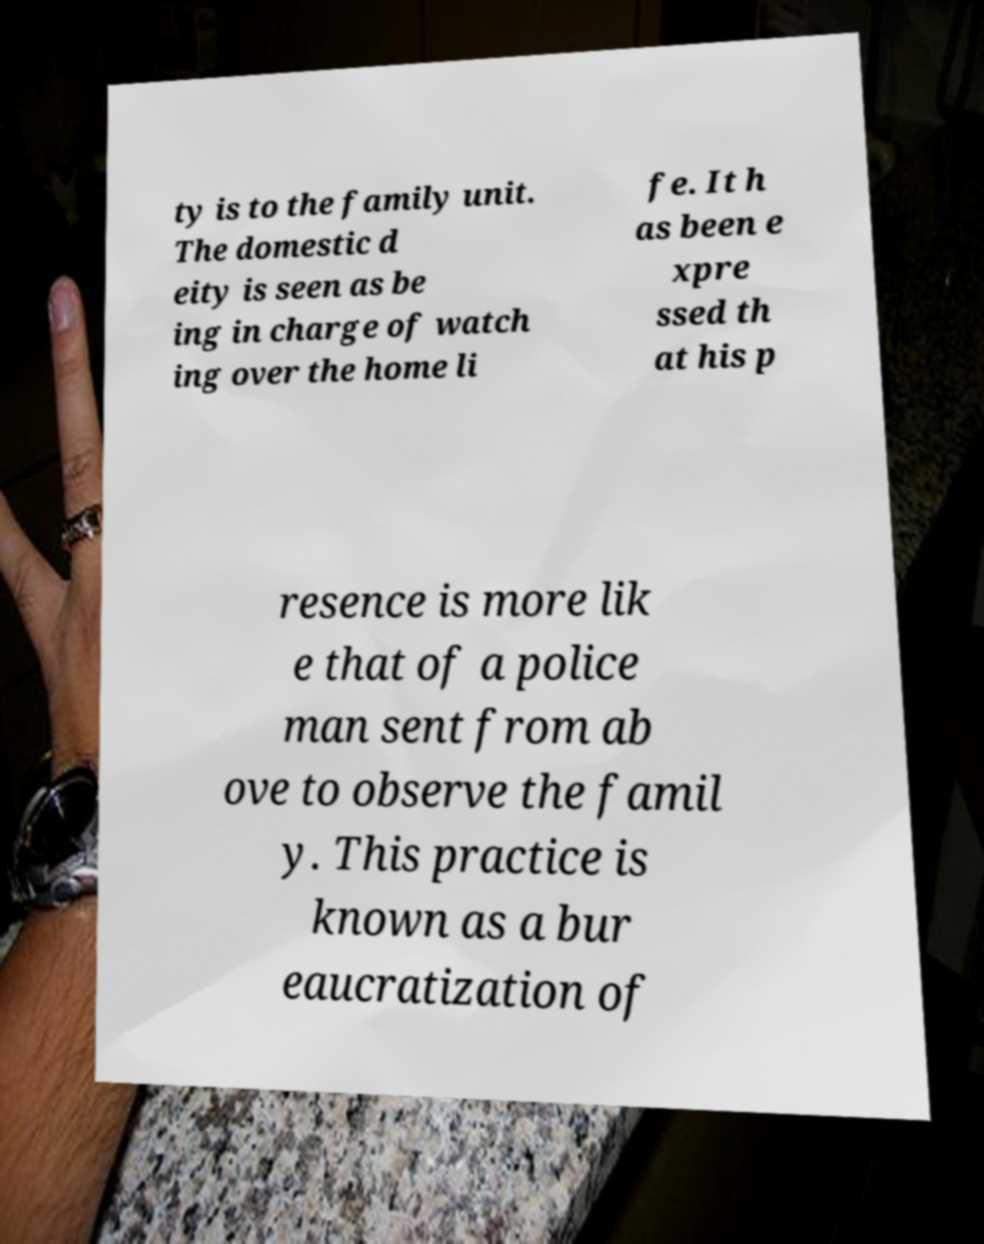Please identify and transcribe the text found in this image. ty is to the family unit. The domestic d eity is seen as be ing in charge of watch ing over the home li fe. It h as been e xpre ssed th at his p resence is more lik e that of a police man sent from ab ove to observe the famil y. This practice is known as a bur eaucratization of 